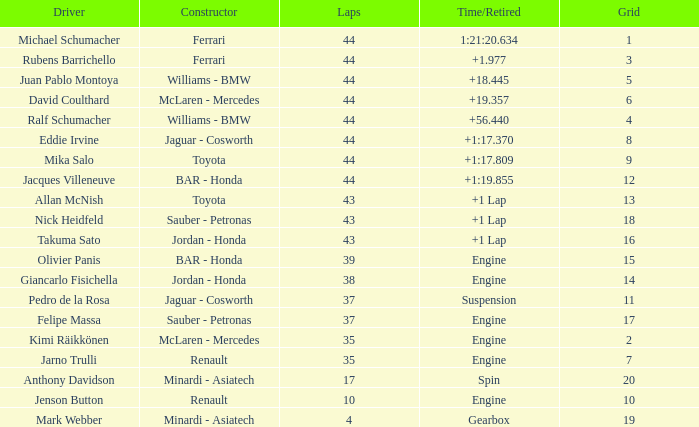What was the time of the driver on grid 3? 1.977. Could you parse the entire table? {'header': ['Driver', 'Constructor', 'Laps', 'Time/Retired', 'Grid'], 'rows': [['Michael Schumacher', 'Ferrari', '44', '1:21:20.634', '1'], ['Rubens Barrichello', 'Ferrari', '44', '+1.977', '3'], ['Juan Pablo Montoya', 'Williams - BMW', '44', '+18.445', '5'], ['David Coulthard', 'McLaren - Mercedes', '44', '+19.357', '6'], ['Ralf Schumacher', 'Williams - BMW', '44', '+56.440', '4'], ['Eddie Irvine', 'Jaguar - Cosworth', '44', '+1:17.370', '8'], ['Mika Salo', 'Toyota', '44', '+1:17.809', '9'], ['Jacques Villeneuve', 'BAR - Honda', '44', '+1:19.855', '12'], ['Allan McNish', 'Toyota', '43', '+1 Lap', '13'], ['Nick Heidfeld', 'Sauber - Petronas', '43', '+1 Lap', '18'], ['Takuma Sato', 'Jordan - Honda', '43', '+1 Lap', '16'], ['Olivier Panis', 'BAR - Honda', '39', 'Engine', '15'], ['Giancarlo Fisichella', 'Jordan - Honda', '38', 'Engine', '14'], ['Pedro de la Rosa', 'Jaguar - Cosworth', '37', 'Suspension', '11'], ['Felipe Massa', 'Sauber - Petronas', '37', 'Engine', '17'], ['Kimi Räikkönen', 'McLaren - Mercedes', '35', 'Engine', '2'], ['Jarno Trulli', 'Renault', '35', 'Engine', '7'], ['Anthony Davidson', 'Minardi - Asiatech', '17', 'Spin', '20'], ['Jenson Button', 'Renault', '10', 'Engine', '10'], ['Mark Webber', 'Minardi - Asiatech', '4', 'Gearbox', '19']]} 